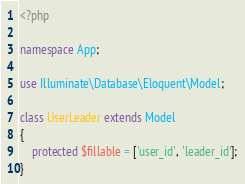Convert code to text. <code><loc_0><loc_0><loc_500><loc_500><_PHP_><?php

namespace App;

use Illuminate\Database\Eloquent\Model;

class UserLeader extends Model
{
    protected $fillable = ['user_id', 'leader_id'];
}
</code> 